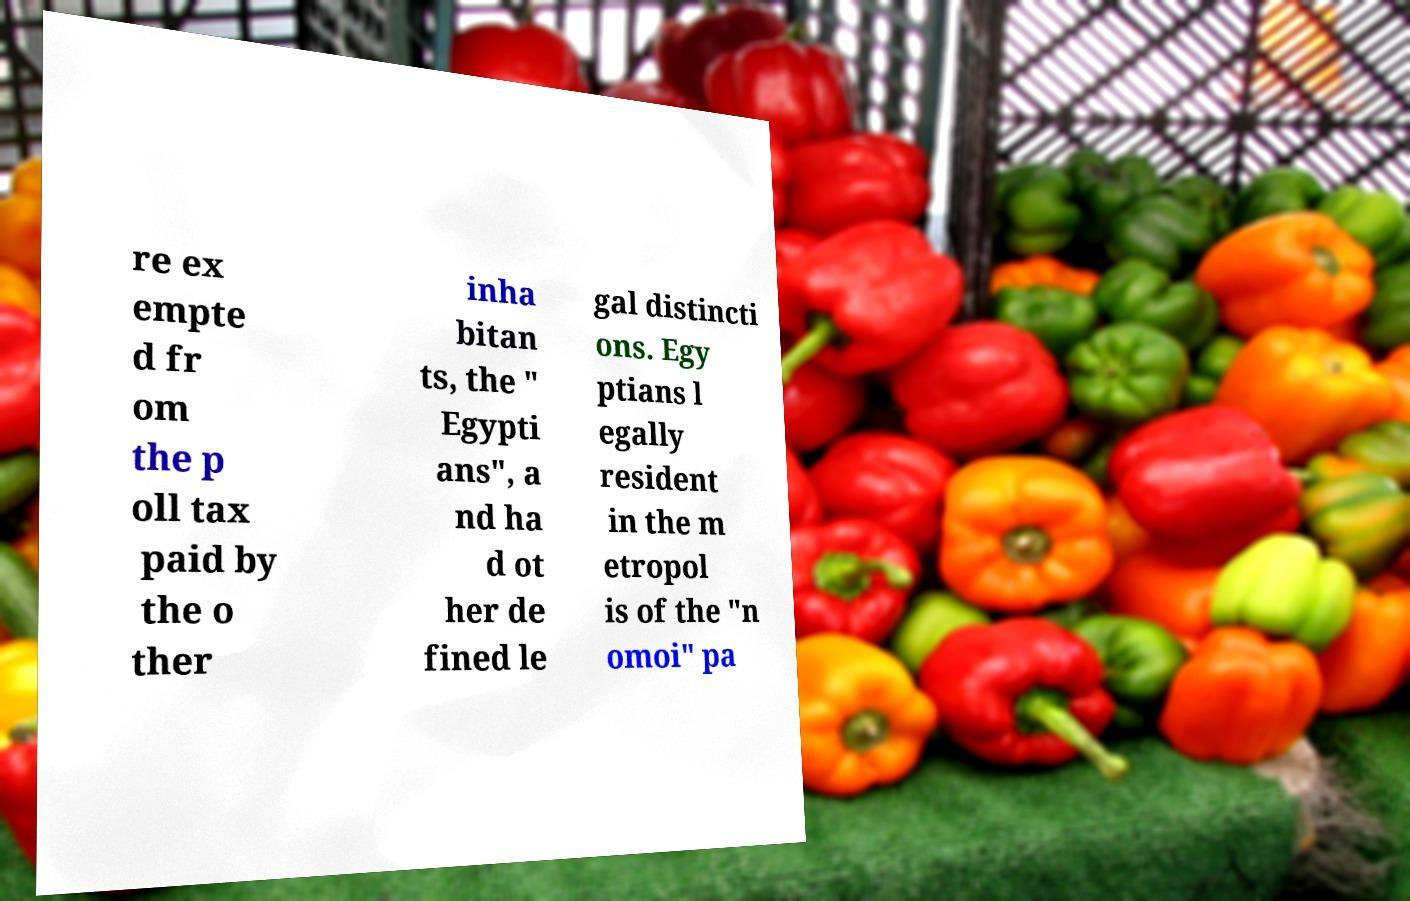Could you assist in decoding the text presented in this image and type it out clearly? re ex empte d fr om the p oll tax paid by the o ther inha bitan ts, the " Egypti ans", a nd ha d ot her de fined le gal distincti ons. Egy ptians l egally resident in the m etropol is of the "n omoi" pa 